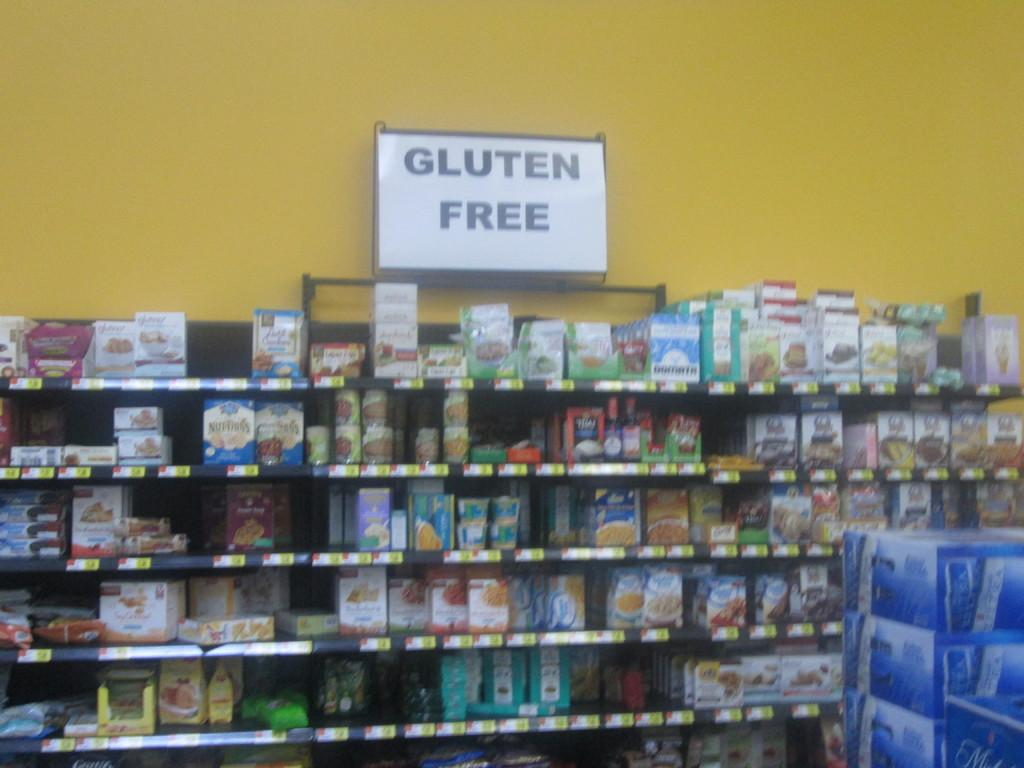Provide a one-sentence caption for the provided image. A shelf of products that advertise that the items are gluten free. 